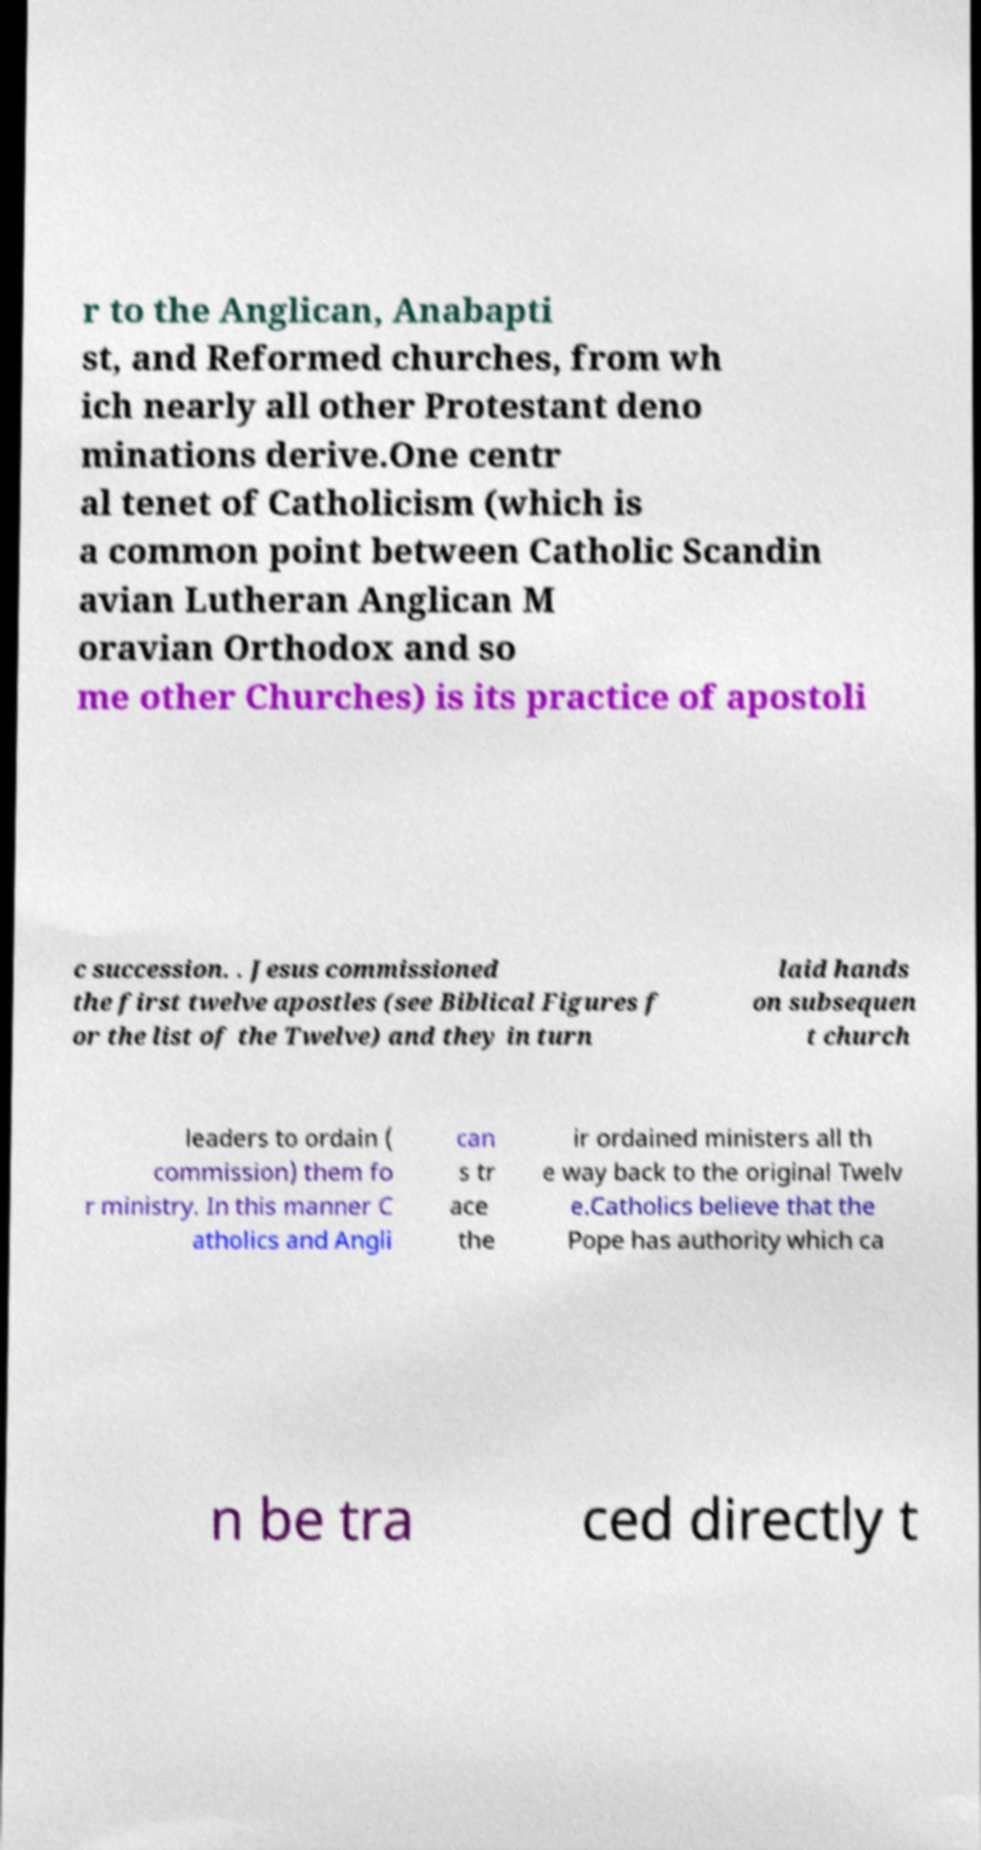Could you extract and type out the text from this image? r to the Anglican, Anabapti st, and Reformed churches, from wh ich nearly all other Protestant deno minations derive.One centr al tenet of Catholicism (which is a common point between Catholic Scandin avian Lutheran Anglican M oravian Orthodox and so me other Churches) is its practice of apostoli c succession. . Jesus commissioned the first twelve apostles (see Biblical Figures f or the list of the Twelve) and they in turn laid hands on subsequen t church leaders to ordain ( commission) them fo r ministry. In this manner C atholics and Angli can s tr ace the ir ordained ministers all th e way back to the original Twelv e.Catholics believe that the Pope has authority which ca n be tra ced directly t 